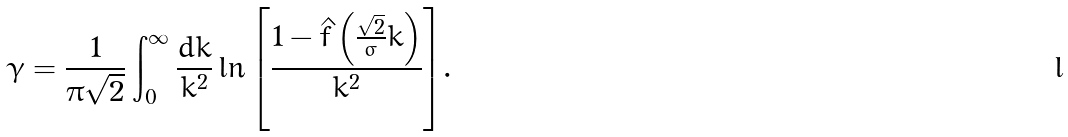<formula> <loc_0><loc_0><loc_500><loc_500>\gamma = \frac { 1 } { \pi \sqrt { 2 } } \int _ { 0 } ^ { \infty } \frac { d k } { k ^ { 2 } } \ln { \left [ \frac { 1 - { \hat { f } } \left ( \frac { \sqrt { 2 } } { \sigma } k \right ) } { k ^ { 2 } } \right ] } .</formula> 